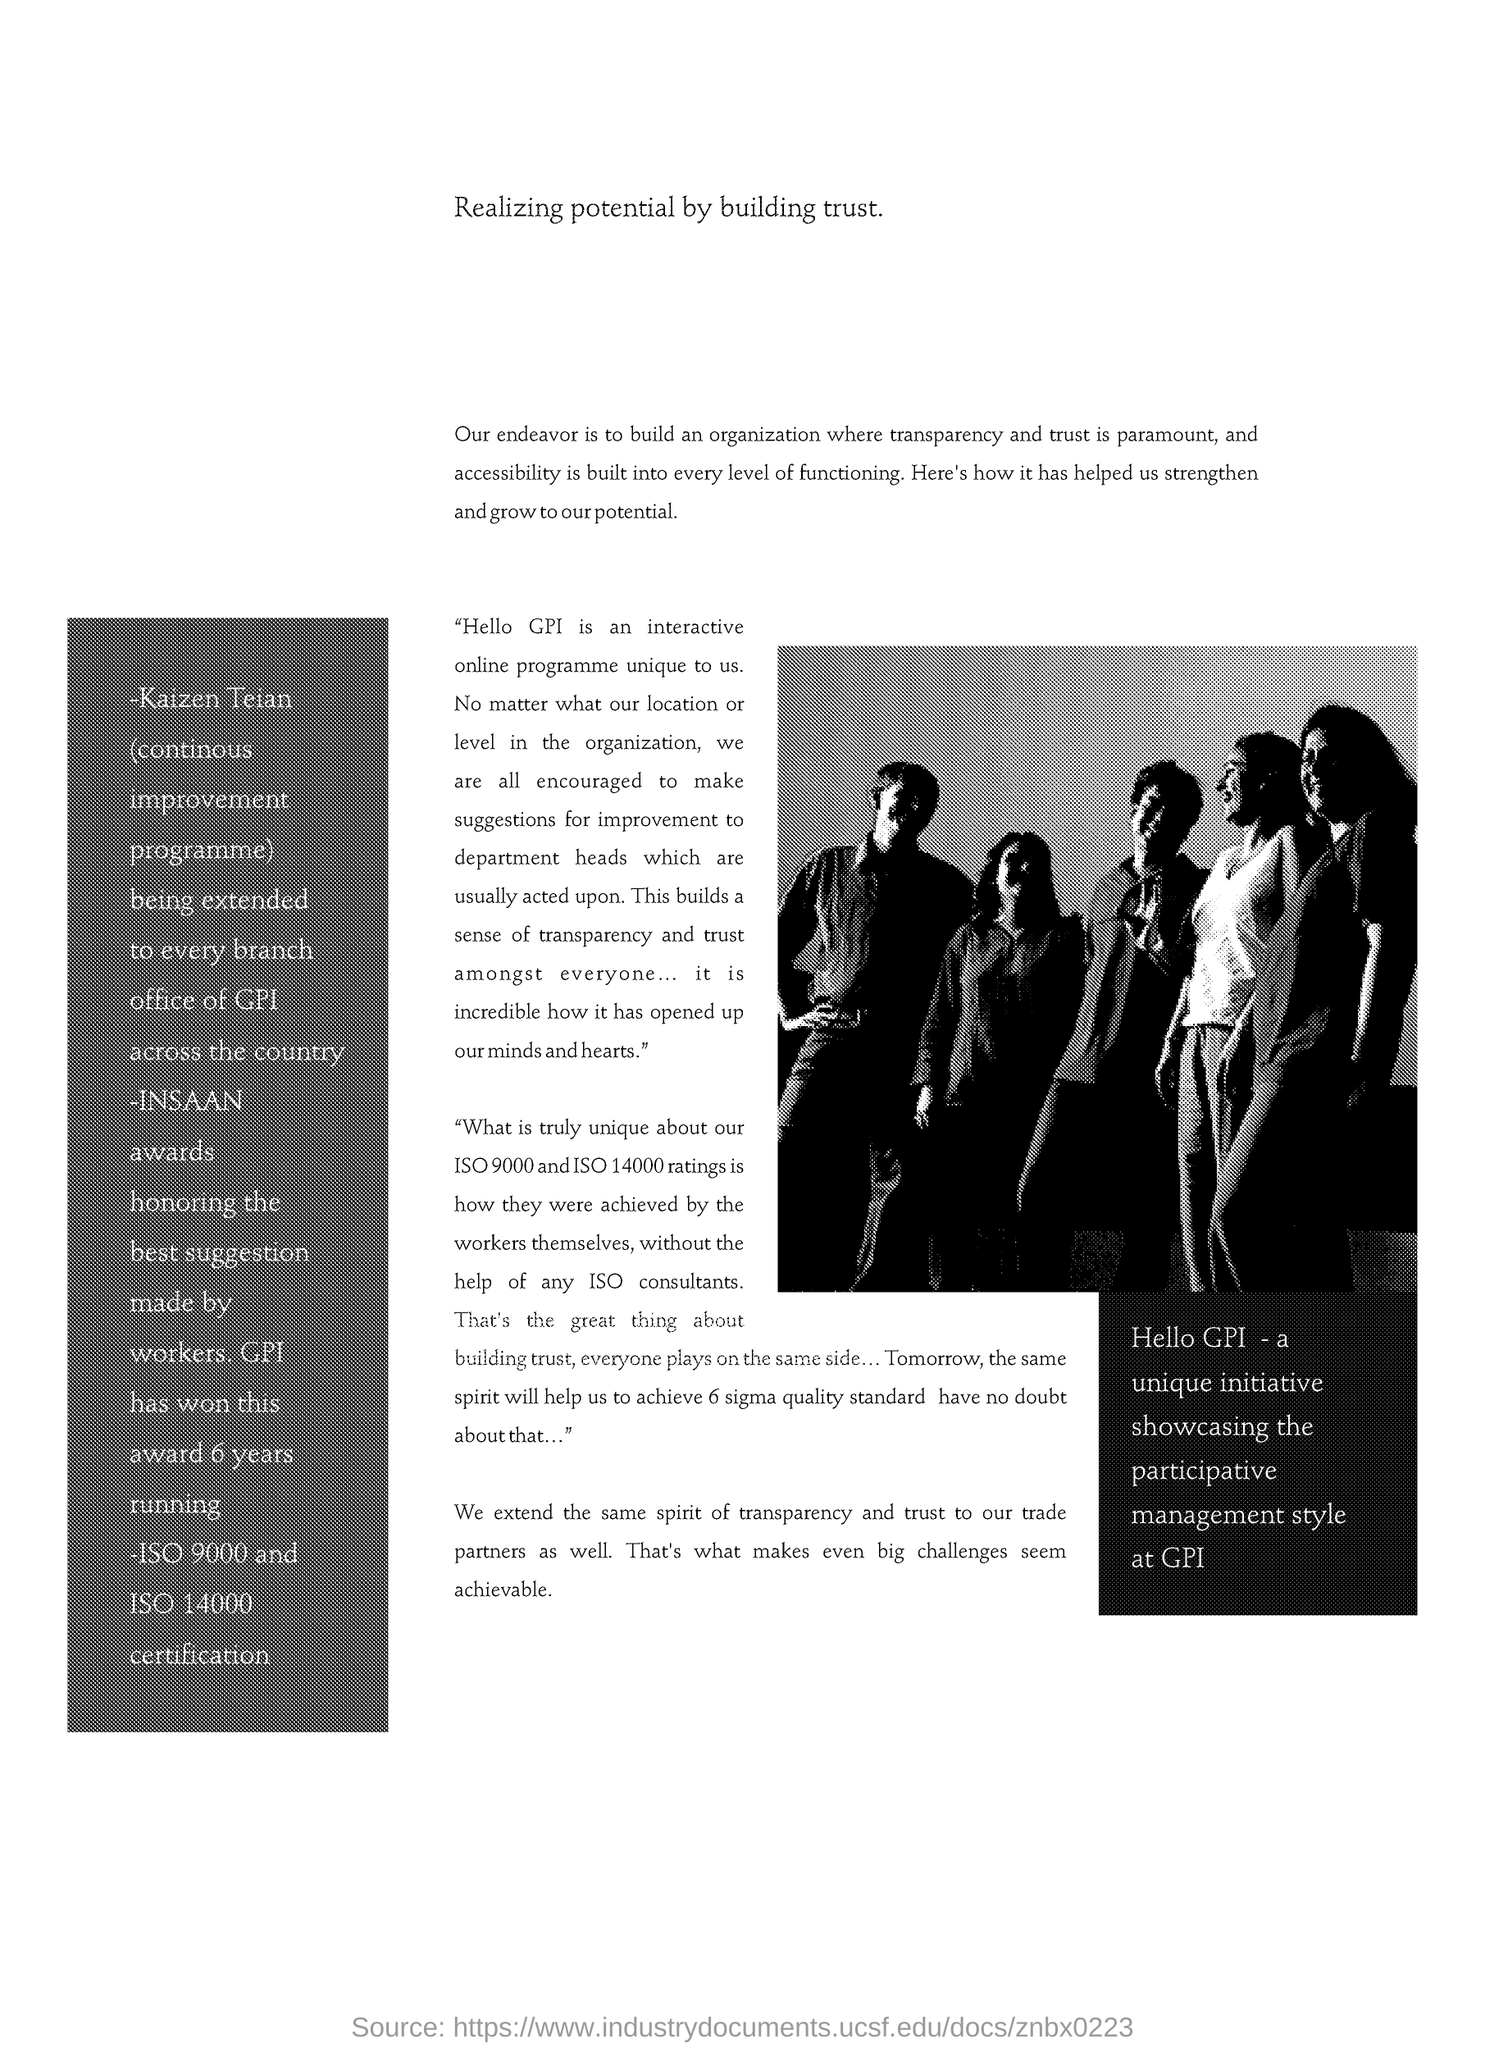What is the title of the document?
Make the answer very short. Realizing potential by building trust. 